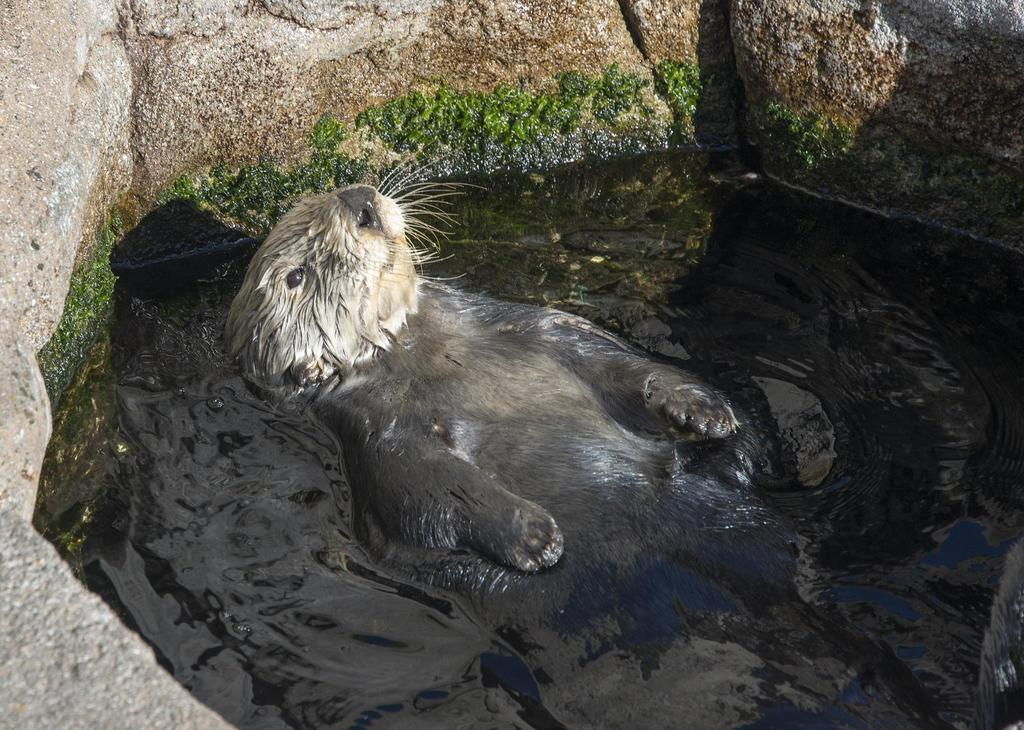What is the animal doing in the water? The fact provided does not specify what the animal is doing in the water. Can you describe the environment in the image? The image features an animal in the water and rocks visible in the background. What type of beam is holding up the bridge in the image? There is no bridge or beam present in the image; it features an animal in the water and rocks visible in the background. 